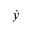<formula> <loc_0><loc_0><loc_500><loc_500>\dot { y }</formula> 